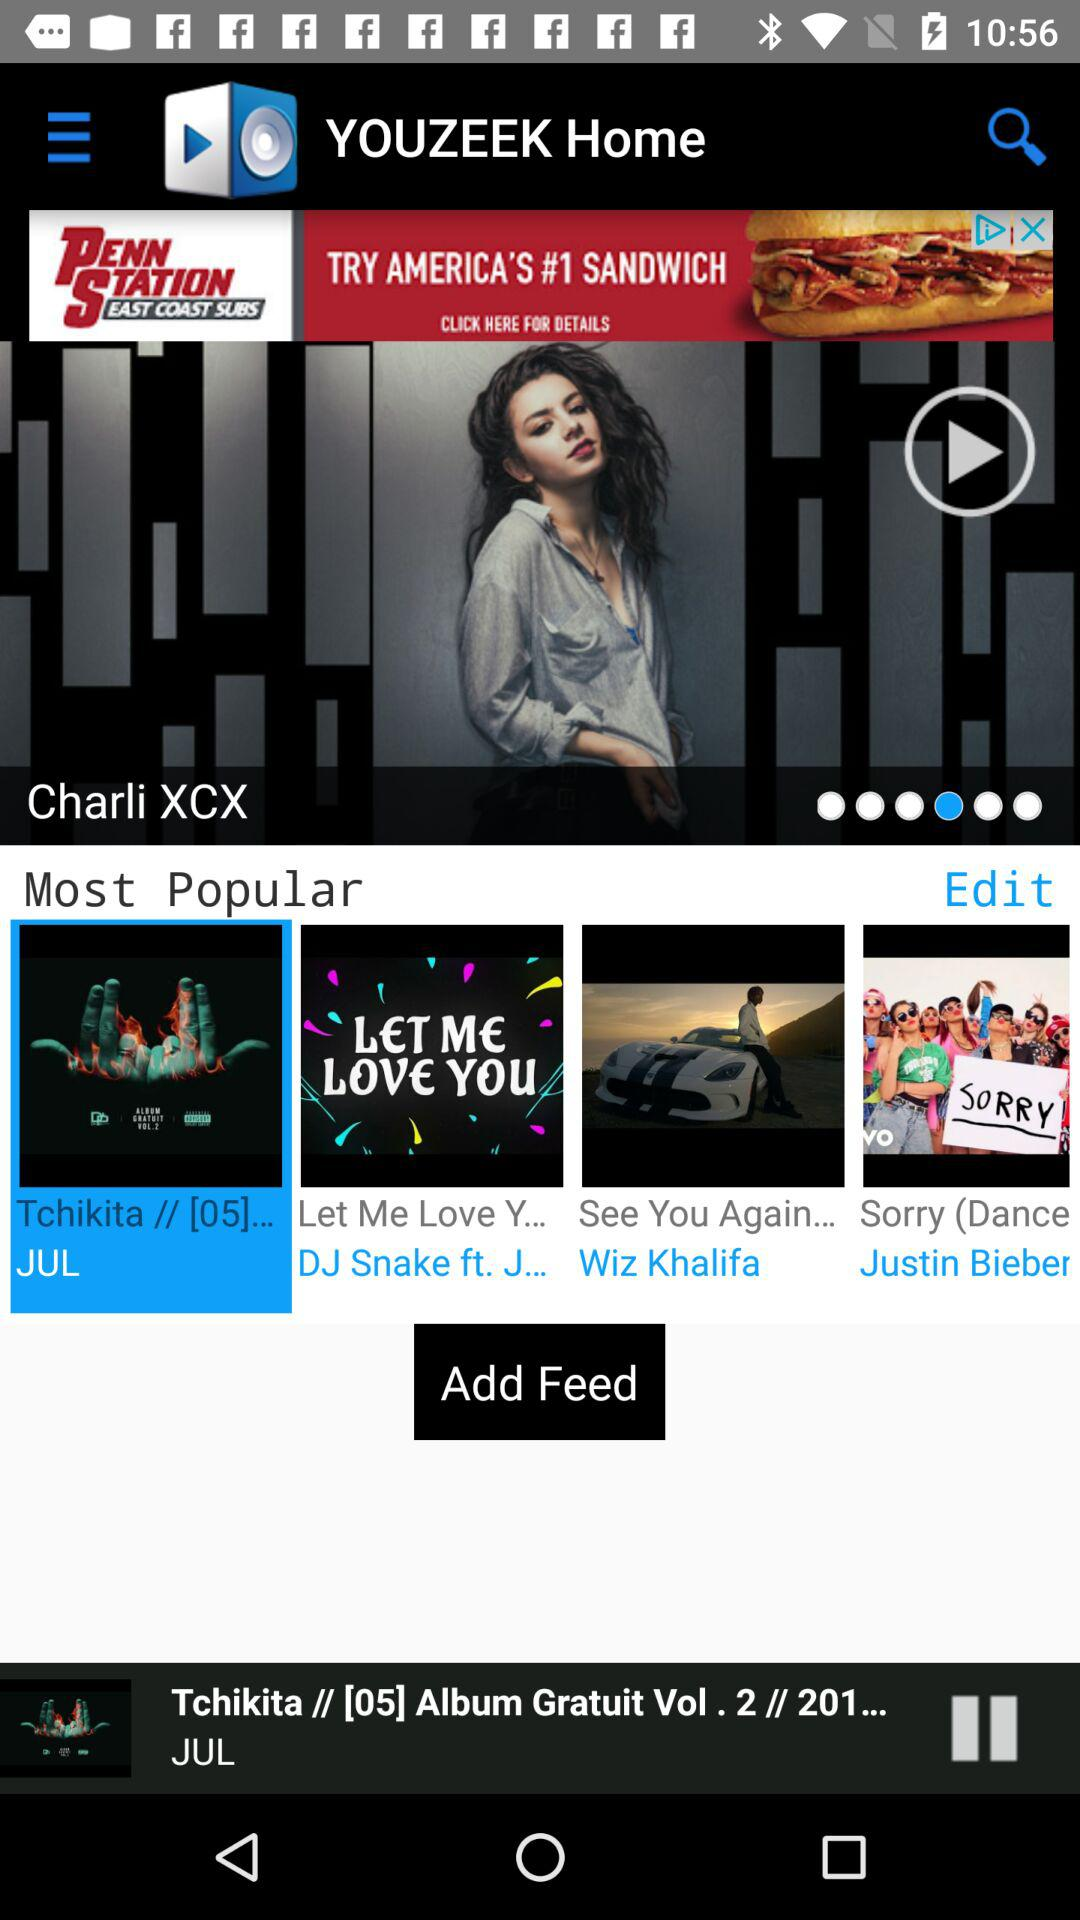Which song is currently playing? The song that is currently playing is "Tchikita // [05] Album Gratuit Vol. 2 // 201...". 